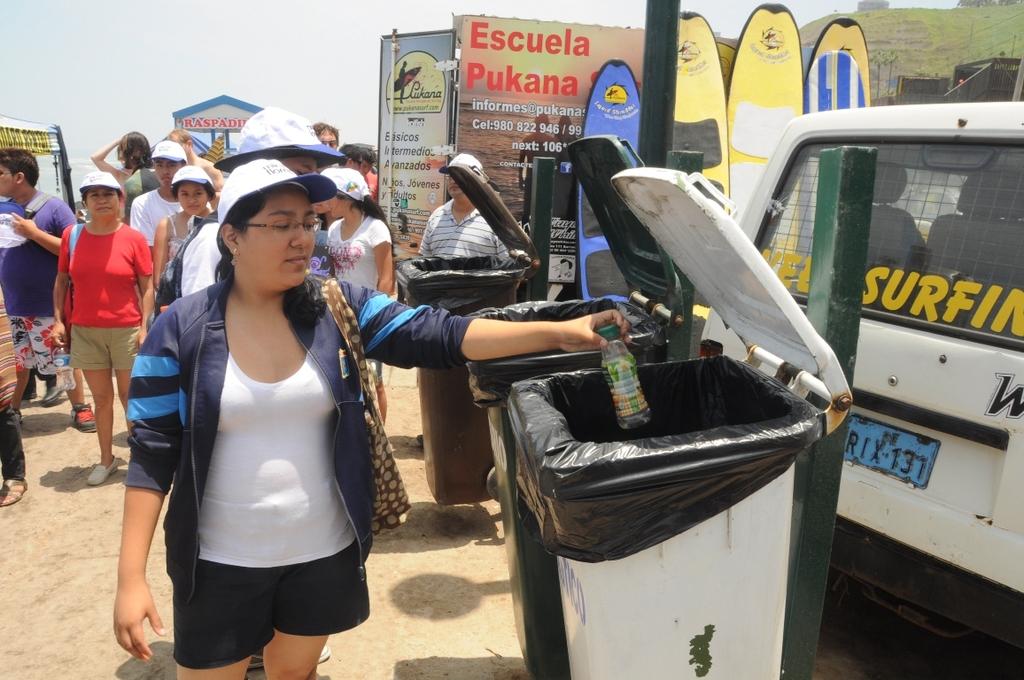What is on the back windshield of that vehivle?
Your answer should be very brief. Surfing. What are the words in red on the sign in the background?
Give a very brief answer. Escuela pukana. 